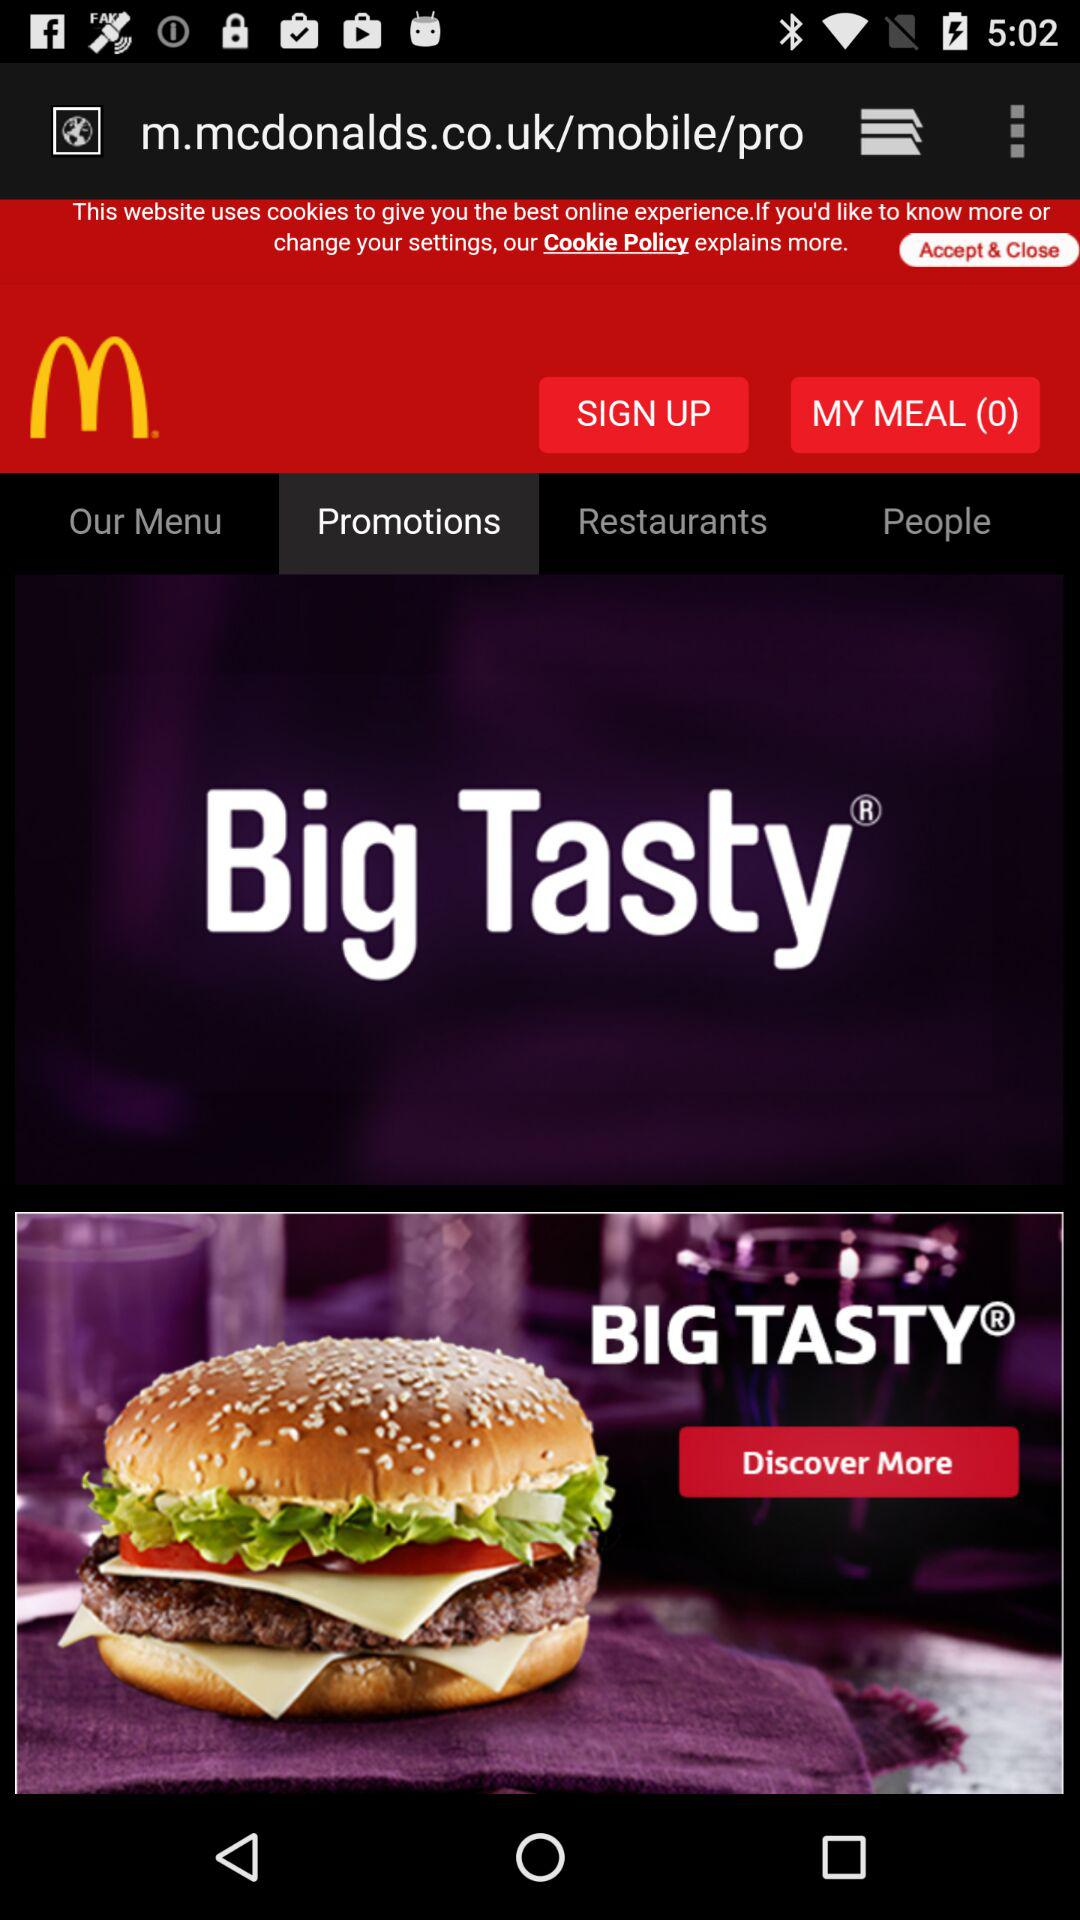On which tab of the application are we? You are on the tab "Promotions". 